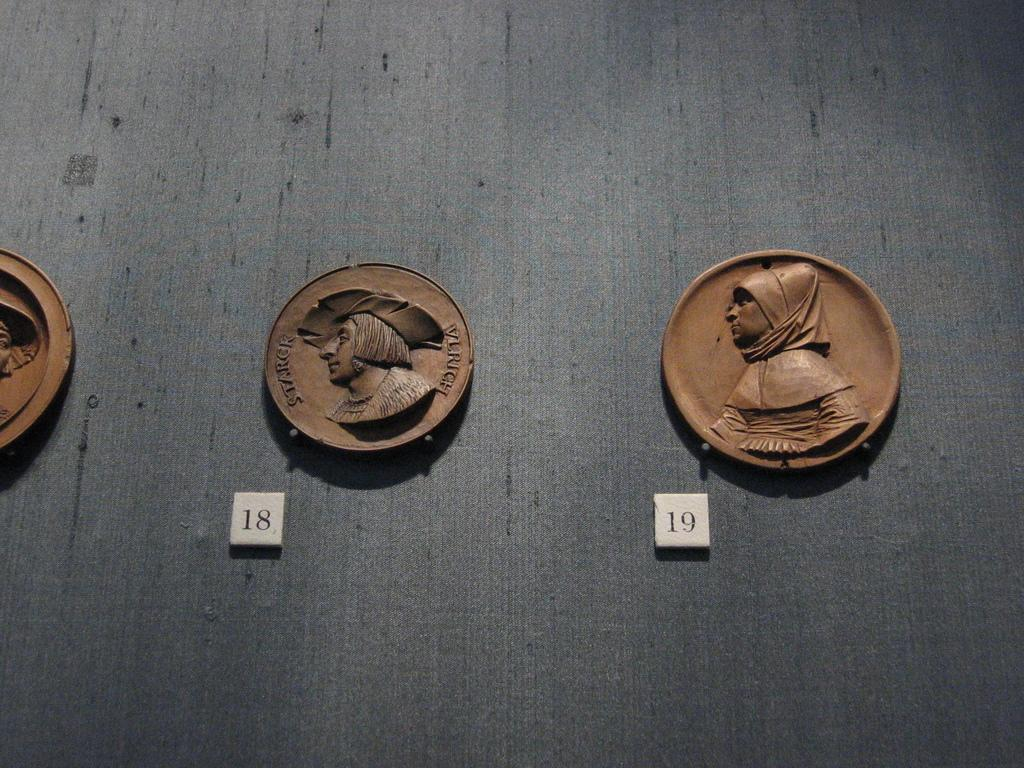Provide a one-sentence caption for the provided image. old terrocotta plates of pilgrims auction numbers 18 and 19. 